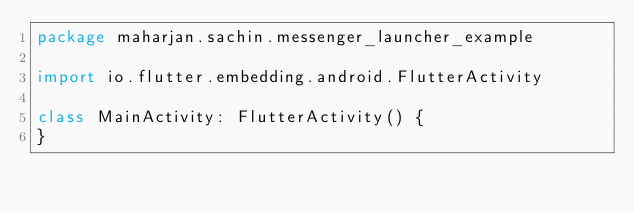Convert code to text. <code><loc_0><loc_0><loc_500><loc_500><_Kotlin_>package maharjan.sachin.messenger_launcher_example

import io.flutter.embedding.android.FlutterActivity

class MainActivity: FlutterActivity() {
}
</code> 